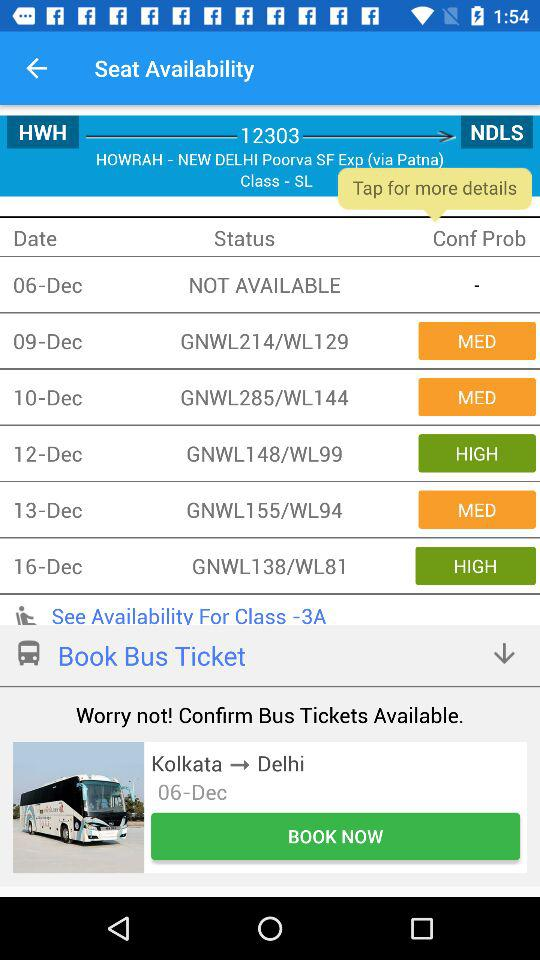What is the source station? The source station is Howrah. 